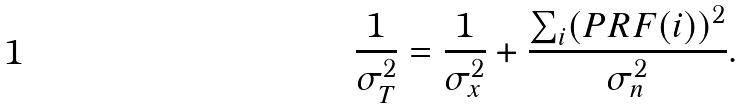Convert formula to latex. <formula><loc_0><loc_0><loc_500><loc_500>\frac { 1 } { \sigma _ { T } ^ { 2 } } = \frac { 1 } { \sigma _ { x } ^ { 2 } } + \frac { \sum _ { i } ( P R F ( i ) ) ^ { 2 } } { \sigma _ { n } ^ { 2 } } .</formula> 